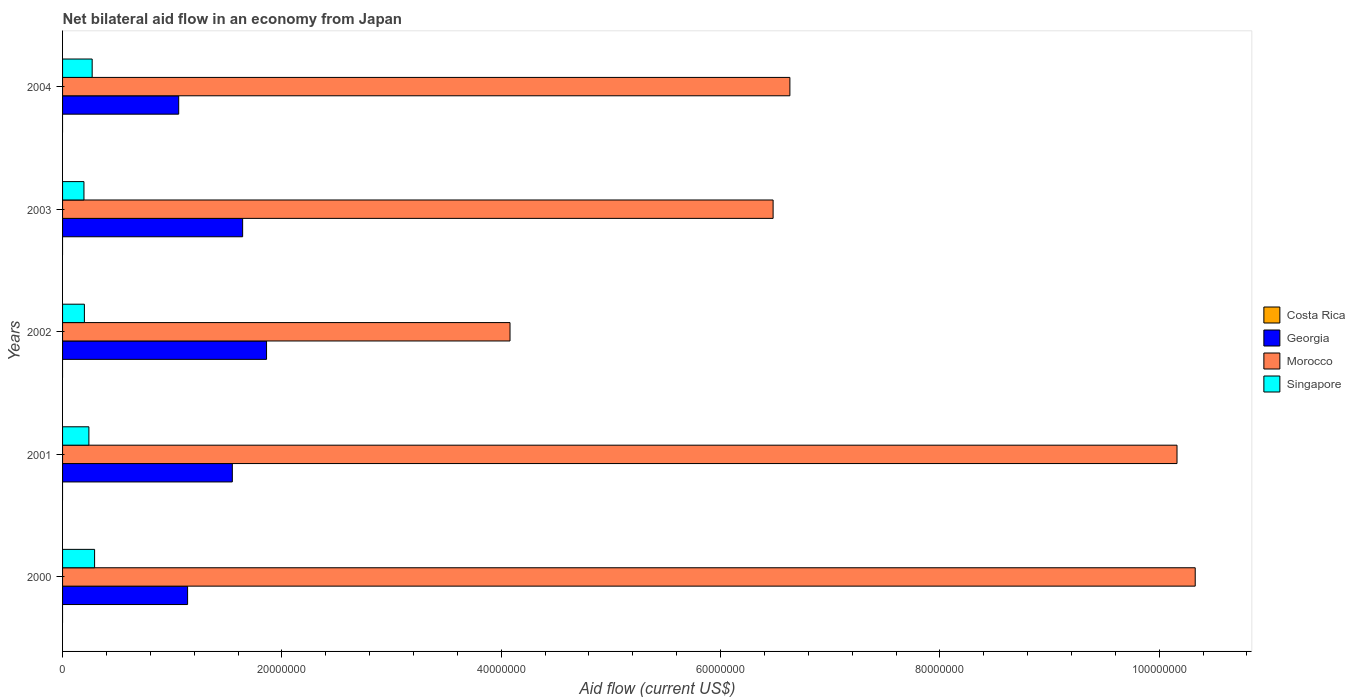How many different coloured bars are there?
Your answer should be very brief. 3. How many bars are there on the 1st tick from the top?
Offer a terse response. 3. How many bars are there on the 1st tick from the bottom?
Your answer should be very brief. 3. What is the net bilateral aid flow in Costa Rica in 2004?
Provide a succinct answer. 0. Across all years, what is the maximum net bilateral aid flow in Georgia?
Make the answer very short. 1.86e+07. Across all years, what is the minimum net bilateral aid flow in Georgia?
Offer a very short reply. 1.06e+07. What is the total net bilateral aid flow in Morocco in the graph?
Your answer should be very brief. 3.77e+08. What is the difference between the net bilateral aid flow in Morocco in 2001 and that in 2003?
Provide a succinct answer. 3.68e+07. What is the difference between the net bilateral aid flow in Singapore in 2000 and the net bilateral aid flow in Costa Rica in 2002?
Provide a succinct answer. 2.92e+06. What is the average net bilateral aid flow in Georgia per year?
Give a very brief answer. 1.45e+07. In the year 2004, what is the difference between the net bilateral aid flow in Georgia and net bilateral aid flow in Morocco?
Your answer should be compact. -5.57e+07. In how many years, is the net bilateral aid flow in Georgia greater than 40000000 US$?
Keep it short and to the point. 0. What is the ratio of the net bilateral aid flow in Georgia in 2001 to that in 2003?
Provide a succinct answer. 0.94. Is the difference between the net bilateral aid flow in Georgia in 2001 and 2003 greater than the difference between the net bilateral aid flow in Morocco in 2001 and 2003?
Offer a terse response. No. What is the difference between the highest and the second highest net bilateral aid flow in Morocco?
Provide a short and direct response. 1.66e+06. What is the difference between the highest and the lowest net bilateral aid flow in Singapore?
Offer a very short reply. 9.70e+05. In how many years, is the net bilateral aid flow in Georgia greater than the average net bilateral aid flow in Georgia taken over all years?
Make the answer very short. 3. Is the sum of the net bilateral aid flow in Morocco in 2001 and 2002 greater than the maximum net bilateral aid flow in Costa Rica across all years?
Your answer should be very brief. Yes. Is it the case that in every year, the sum of the net bilateral aid flow in Costa Rica and net bilateral aid flow in Morocco is greater than the sum of net bilateral aid flow in Georgia and net bilateral aid flow in Singapore?
Offer a very short reply. No. How many bars are there?
Your response must be concise. 15. How many years are there in the graph?
Make the answer very short. 5. Are the values on the major ticks of X-axis written in scientific E-notation?
Offer a terse response. No. Where does the legend appear in the graph?
Give a very brief answer. Center right. What is the title of the graph?
Ensure brevity in your answer.  Net bilateral aid flow in an economy from Japan. Does "Germany" appear as one of the legend labels in the graph?
Offer a very short reply. No. What is the label or title of the Y-axis?
Your answer should be compact. Years. What is the Aid flow (current US$) in Georgia in 2000?
Your answer should be compact. 1.14e+07. What is the Aid flow (current US$) of Morocco in 2000?
Your response must be concise. 1.03e+08. What is the Aid flow (current US$) of Singapore in 2000?
Make the answer very short. 2.92e+06. What is the Aid flow (current US$) of Costa Rica in 2001?
Provide a short and direct response. 0. What is the Aid flow (current US$) in Georgia in 2001?
Provide a succinct answer. 1.55e+07. What is the Aid flow (current US$) in Morocco in 2001?
Offer a very short reply. 1.02e+08. What is the Aid flow (current US$) in Singapore in 2001?
Provide a succinct answer. 2.40e+06. What is the Aid flow (current US$) in Georgia in 2002?
Give a very brief answer. 1.86e+07. What is the Aid flow (current US$) in Morocco in 2002?
Your answer should be compact. 4.08e+07. What is the Aid flow (current US$) in Singapore in 2002?
Offer a terse response. 1.99e+06. What is the Aid flow (current US$) in Costa Rica in 2003?
Offer a terse response. 0. What is the Aid flow (current US$) in Georgia in 2003?
Offer a very short reply. 1.64e+07. What is the Aid flow (current US$) in Morocco in 2003?
Keep it short and to the point. 6.48e+07. What is the Aid flow (current US$) in Singapore in 2003?
Your response must be concise. 1.95e+06. What is the Aid flow (current US$) of Georgia in 2004?
Provide a short and direct response. 1.06e+07. What is the Aid flow (current US$) in Morocco in 2004?
Make the answer very short. 6.63e+07. What is the Aid flow (current US$) of Singapore in 2004?
Your response must be concise. 2.70e+06. Across all years, what is the maximum Aid flow (current US$) of Georgia?
Keep it short and to the point. 1.86e+07. Across all years, what is the maximum Aid flow (current US$) in Morocco?
Give a very brief answer. 1.03e+08. Across all years, what is the maximum Aid flow (current US$) of Singapore?
Give a very brief answer. 2.92e+06. Across all years, what is the minimum Aid flow (current US$) of Georgia?
Keep it short and to the point. 1.06e+07. Across all years, what is the minimum Aid flow (current US$) of Morocco?
Provide a short and direct response. 4.08e+07. Across all years, what is the minimum Aid flow (current US$) in Singapore?
Offer a very short reply. 1.95e+06. What is the total Aid flow (current US$) of Costa Rica in the graph?
Ensure brevity in your answer.  0. What is the total Aid flow (current US$) of Georgia in the graph?
Your answer should be very brief. 7.25e+07. What is the total Aid flow (current US$) in Morocco in the graph?
Your response must be concise. 3.77e+08. What is the total Aid flow (current US$) in Singapore in the graph?
Provide a short and direct response. 1.20e+07. What is the difference between the Aid flow (current US$) in Georgia in 2000 and that in 2001?
Your answer should be very brief. -4.08e+06. What is the difference between the Aid flow (current US$) of Morocco in 2000 and that in 2001?
Your answer should be compact. 1.66e+06. What is the difference between the Aid flow (current US$) in Singapore in 2000 and that in 2001?
Offer a very short reply. 5.20e+05. What is the difference between the Aid flow (current US$) in Georgia in 2000 and that in 2002?
Your answer should be very brief. -7.20e+06. What is the difference between the Aid flow (current US$) of Morocco in 2000 and that in 2002?
Your response must be concise. 6.25e+07. What is the difference between the Aid flow (current US$) in Singapore in 2000 and that in 2002?
Your answer should be compact. 9.30e+05. What is the difference between the Aid flow (current US$) in Georgia in 2000 and that in 2003?
Offer a very short reply. -5.02e+06. What is the difference between the Aid flow (current US$) in Morocco in 2000 and that in 2003?
Make the answer very short. 3.85e+07. What is the difference between the Aid flow (current US$) in Singapore in 2000 and that in 2003?
Ensure brevity in your answer.  9.70e+05. What is the difference between the Aid flow (current US$) in Georgia in 2000 and that in 2004?
Keep it short and to the point. 8.10e+05. What is the difference between the Aid flow (current US$) of Morocco in 2000 and that in 2004?
Make the answer very short. 3.70e+07. What is the difference between the Aid flow (current US$) in Singapore in 2000 and that in 2004?
Give a very brief answer. 2.20e+05. What is the difference between the Aid flow (current US$) in Georgia in 2001 and that in 2002?
Keep it short and to the point. -3.12e+06. What is the difference between the Aid flow (current US$) in Morocco in 2001 and that in 2002?
Keep it short and to the point. 6.08e+07. What is the difference between the Aid flow (current US$) in Georgia in 2001 and that in 2003?
Give a very brief answer. -9.40e+05. What is the difference between the Aid flow (current US$) in Morocco in 2001 and that in 2003?
Your response must be concise. 3.68e+07. What is the difference between the Aid flow (current US$) of Singapore in 2001 and that in 2003?
Your response must be concise. 4.50e+05. What is the difference between the Aid flow (current US$) of Georgia in 2001 and that in 2004?
Provide a succinct answer. 4.89e+06. What is the difference between the Aid flow (current US$) in Morocco in 2001 and that in 2004?
Make the answer very short. 3.53e+07. What is the difference between the Aid flow (current US$) of Georgia in 2002 and that in 2003?
Your response must be concise. 2.18e+06. What is the difference between the Aid flow (current US$) of Morocco in 2002 and that in 2003?
Your answer should be compact. -2.40e+07. What is the difference between the Aid flow (current US$) in Singapore in 2002 and that in 2003?
Offer a very short reply. 4.00e+04. What is the difference between the Aid flow (current US$) of Georgia in 2002 and that in 2004?
Provide a succinct answer. 8.01e+06. What is the difference between the Aid flow (current US$) of Morocco in 2002 and that in 2004?
Make the answer very short. -2.55e+07. What is the difference between the Aid flow (current US$) in Singapore in 2002 and that in 2004?
Ensure brevity in your answer.  -7.10e+05. What is the difference between the Aid flow (current US$) of Georgia in 2003 and that in 2004?
Provide a short and direct response. 5.83e+06. What is the difference between the Aid flow (current US$) of Morocco in 2003 and that in 2004?
Offer a very short reply. -1.53e+06. What is the difference between the Aid flow (current US$) of Singapore in 2003 and that in 2004?
Give a very brief answer. -7.50e+05. What is the difference between the Aid flow (current US$) of Georgia in 2000 and the Aid flow (current US$) of Morocco in 2001?
Your answer should be very brief. -9.02e+07. What is the difference between the Aid flow (current US$) in Georgia in 2000 and the Aid flow (current US$) in Singapore in 2001?
Make the answer very short. 9.00e+06. What is the difference between the Aid flow (current US$) of Morocco in 2000 and the Aid flow (current US$) of Singapore in 2001?
Your answer should be very brief. 1.01e+08. What is the difference between the Aid flow (current US$) of Georgia in 2000 and the Aid flow (current US$) of Morocco in 2002?
Provide a succinct answer. -2.94e+07. What is the difference between the Aid flow (current US$) of Georgia in 2000 and the Aid flow (current US$) of Singapore in 2002?
Your answer should be compact. 9.41e+06. What is the difference between the Aid flow (current US$) in Morocco in 2000 and the Aid flow (current US$) in Singapore in 2002?
Provide a succinct answer. 1.01e+08. What is the difference between the Aid flow (current US$) of Georgia in 2000 and the Aid flow (current US$) of Morocco in 2003?
Give a very brief answer. -5.34e+07. What is the difference between the Aid flow (current US$) in Georgia in 2000 and the Aid flow (current US$) in Singapore in 2003?
Ensure brevity in your answer.  9.45e+06. What is the difference between the Aid flow (current US$) of Morocco in 2000 and the Aid flow (current US$) of Singapore in 2003?
Your answer should be compact. 1.01e+08. What is the difference between the Aid flow (current US$) in Georgia in 2000 and the Aid flow (current US$) in Morocco in 2004?
Offer a terse response. -5.49e+07. What is the difference between the Aid flow (current US$) in Georgia in 2000 and the Aid flow (current US$) in Singapore in 2004?
Your answer should be compact. 8.70e+06. What is the difference between the Aid flow (current US$) of Morocco in 2000 and the Aid flow (current US$) of Singapore in 2004?
Keep it short and to the point. 1.01e+08. What is the difference between the Aid flow (current US$) of Georgia in 2001 and the Aid flow (current US$) of Morocco in 2002?
Your answer should be very brief. -2.53e+07. What is the difference between the Aid flow (current US$) in Georgia in 2001 and the Aid flow (current US$) in Singapore in 2002?
Keep it short and to the point. 1.35e+07. What is the difference between the Aid flow (current US$) in Morocco in 2001 and the Aid flow (current US$) in Singapore in 2002?
Your response must be concise. 9.96e+07. What is the difference between the Aid flow (current US$) in Georgia in 2001 and the Aid flow (current US$) in Morocco in 2003?
Your answer should be very brief. -4.93e+07. What is the difference between the Aid flow (current US$) of Georgia in 2001 and the Aid flow (current US$) of Singapore in 2003?
Your answer should be compact. 1.35e+07. What is the difference between the Aid flow (current US$) in Morocco in 2001 and the Aid flow (current US$) in Singapore in 2003?
Offer a very short reply. 9.97e+07. What is the difference between the Aid flow (current US$) in Georgia in 2001 and the Aid flow (current US$) in Morocco in 2004?
Your response must be concise. -5.08e+07. What is the difference between the Aid flow (current US$) in Georgia in 2001 and the Aid flow (current US$) in Singapore in 2004?
Your answer should be compact. 1.28e+07. What is the difference between the Aid flow (current US$) of Morocco in 2001 and the Aid flow (current US$) of Singapore in 2004?
Your response must be concise. 9.89e+07. What is the difference between the Aid flow (current US$) in Georgia in 2002 and the Aid flow (current US$) in Morocco in 2003?
Offer a very short reply. -4.62e+07. What is the difference between the Aid flow (current US$) in Georgia in 2002 and the Aid flow (current US$) in Singapore in 2003?
Give a very brief answer. 1.66e+07. What is the difference between the Aid flow (current US$) of Morocco in 2002 and the Aid flow (current US$) of Singapore in 2003?
Ensure brevity in your answer.  3.88e+07. What is the difference between the Aid flow (current US$) in Georgia in 2002 and the Aid flow (current US$) in Morocco in 2004?
Your response must be concise. -4.77e+07. What is the difference between the Aid flow (current US$) in Georgia in 2002 and the Aid flow (current US$) in Singapore in 2004?
Offer a terse response. 1.59e+07. What is the difference between the Aid flow (current US$) in Morocco in 2002 and the Aid flow (current US$) in Singapore in 2004?
Give a very brief answer. 3.81e+07. What is the difference between the Aid flow (current US$) of Georgia in 2003 and the Aid flow (current US$) of Morocco in 2004?
Provide a short and direct response. -4.99e+07. What is the difference between the Aid flow (current US$) of Georgia in 2003 and the Aid flow (current US$) of Singapore in 2004?
Give a very brief answer. 1.37e+07. What is the difference between the Aid flow (current US$) of Morocco in 2003 and the Aid flow (current US$) of Singapore in 2004?
Your answer should be compact. 6.21e+07. What is the average Aid flow (current US$) of Georgia per year?
Keep it short and to the point. 1.45e+07. What is the average Aid flow (current US$) in Morocco per year?
Offer a very short reply. 7.54e+07. What is the average Aid flow (current US$) in Singapore per year?
Offer a very short reply. 2.39e+06. In the year 2000, what is the difference between the Aid flow (current US$) in Georgia and Aid flow (current US$) in Morocco?
Your response must be concise. -9.19e+07. In the year 2000, what is the difference between the Aid flow (current US$) in Georgia and Aid flow (current US$) in Singapore?
Ensure brevity in your answer.  8.48e+06. In the year 2000, what is the difference between the Aid flow (current US$) in Morocco and Aid flow (current US$) in Singapore?
Offer a terse response. 1.00e+08. In the year 2001, what is the difference between the Aid flow (current US$) of Georgia and Aid flow (current US$) of Morocco?
Provide a succinct answer. -8.61e+07. In the year 2001, what is the difference between the Aid flow (current US$) of Georgia and Aid flow (current US$) of Singapore?
Make the answer very short. 1.31e+07. In the year 2001, what is the difference between the Aid flow (current US$) of Morocco and Aid flow (current US$) of Singapore?
Provide a short and direct response. 9.92e+07. In the year 2002, what is the difference between the Aid flow (current US$) in Georgia and Aid flow (current US$) in Morocco?
Your response must be concise. -2.22e+07. In the year 2002, what is the difference between the Aid flow (current US$) in Georgia and Aid flow (current US$) in Singapore?
Provide a short and direct response. 1.66e+07. In the year 2002, what is the difference between the Aid flow (current US$) of Morocco and Aid flow (current US$) of Singapore?
Offer a terse response. 3.88e+07. In the year 2003, what is the difference between the Aid flow (current US$) of Georgia and Aid flow (current US$) of Morocco?
Ensure brevity in your answer.  -4.84e+07. In the year 2003, what is the difference between the Aid flow (current US$) of Georgia and Aid flow (current US$) of Singapore?
Give a very brief answer. 1.45e+07. In the year 2003, what is the difference between the Aid flow (current US$) in Morocco and Aid flow (current US$) in Singapore?
Make the answer very short. 6.28e+07. In the year 2004, what is the difference between the Aid flow (current US$) in Georgia and Aid flow (current US$) in Morocco?
Offer a terse response. -5.57e+07. In the year 2004, what is the difference between the Aid flow (current US$) in Georgia and Aid flow (current US$) in Singapore?
Offer a terse response. 7.89e+06. In the year 2004, what is the difference between the Aid flow (current US$) in Morocco and Aid flow (current US$) in Singapore?
Give a very brief answer. 6.36e+07. What is the ratio of the Aid flow (current US$) of Georgia in 2000 to that in 2001?
Offer a terse response. 0.74. What is the ratio of the Aid flow (current US$) of Morocco in 2000 to that in 2001?
Make the answer very short. 1.02. What is the ratio of the Aid flow (current US$) of Singapore in 2000 to that in 2001?
Offer a very short reply. 1.22. What is the ratio of the Aid flow (current US$) of Georgia in 2000 to that in 2002?
Provide a short and direct response. 0.61. What is the ratio of the Aid flow (current US$) in Morocco in 2000 to that in 2002?
Give a very brief answer. 2.53. What is the ratio of the Aid flow (current US$) of Singapore in 2000 to that in 2002?
Your answer should be very brief. 1.47. What is the ratio of the Aid flow (current US$) of Georgia in 2000 to that in 2003?
Give a very brief answer. 0.69. What is the ratio of the Aid flow (current US$) of Morocco in 2000 to that in 2003?
Make the answer very short. 1.59. What is the ratio of the Aid flow (current US$) of Singapore in 2000 to that in 2003?
Offer a very short reply. 1.5. What is the ratio of the Aid flow (current US$) of Georgia in 2000 to that in 2004?
Offer a very short reply. 1.08. What is the ratio of the Aid flow (current US$) of Morocco in 2000 to that in 2004?
Give a very brief answer. 1.56. What is the ratio of the Aid flow (current US$) in Singapore in 2000 to that in 2004?
Your response must be concise. 1.08. What is the ratio of the Aid flow (current US$) in Georgia in 2001 to that in 2002?
Your answer should be compact. 0.83. What is the ratio of the Aid flow (current US$) in Morocco in 2001 to that in 2002?
Keep it short and to the point. 2.49. What is the ratio of the Aid flow (current US$) of Singapore in 2001 to that in 2002?
Offer a very short reply. 1.21. What is the ratio of the Aid flow (current US$) in Georgia in 2001 to that in 2003?
Ensure brevity in your answer.  0.94. What is the ratio of the Aid flow (current US$) in Morocco in 2001 to that in 2003?
Keep it short and to the point. 1.57. What is the ratio of the Aid flow (current US$) in Singapore in 2001 to that in 2003?
Make the answer very short. 1.23. What is the ratio of the Aid flow (current US$) in Georgia in 2001 to that in 2004?
Your response must be concise. 1.46. What is the ratio of the Aid flow (current US$) of Morocco in 2001 to that in 2004?
Your answer should be compact. 1.53. What is the ratio of the Aid flow (current US$) in Georgia in 2002 to that in 2003?
Offer a very short reply. 1.13. What is the ratio of the Aid flow (current US$) in Morocco in 2002 to that in 2003?
Offer a terse response. 0.63. What is the ratio of the Aid flow (current US$) of Singapore in 2002 to that in 2003?
Provide a short and direct response. 1.02. What is the ratio of the Aid flow (current US$) in Georgia in 2002 to that in 2004?
Your answer should be compact. 1.76. What is the ratio of the Aid flow (current US$) of Morocco in 2002 to that in 2004?
Your answer should be very brief. 0.62. What is the ratio of the Aid flow (current US$) of Singapore in 2002 to that in 2004?
Ensure brevity in your answer.  0.74. What is the ratio of the Aid flow (current US$) in Georgia in 2003 to that in 2004?
Your response must be concise. 1.55. What is the ratio of the Aid flow (current US$) of Morocco in 2003 to that in 2004?
Your answer should be compact. 0.98. What is the ratio of the Aid flow (current US$) in Singapore in 2003 to that in 2004?
Your answer should be compact. 0.72. What is the difference between the highest and the second highest Aid flow (current US$) of Georgia?
Make the answer very short. 2.18e+06. What is the difference between the highest and the second highest Aid flow (current US$) in Morocco?
Keep it short and to the point. 1.66e+06. What is the difference between the highest and the second highest Aid flow (current US$) of Singapore?
Ensure brevity in your answer.  2.20e+05. What is the difference between the highest and the lowest Aid flow (current US$) in Georgia?
Provide a short and direct response. 8.01e+06. What is the difference between the highest and the lowest Aid flow (current US$) of Morocco?
Make the answer very short. 6.25e+07. What is the difference between the highest and the lowest Aid flow (current US$) of Singapore?
Ensure brevity in your answer.  9.70e+05. 